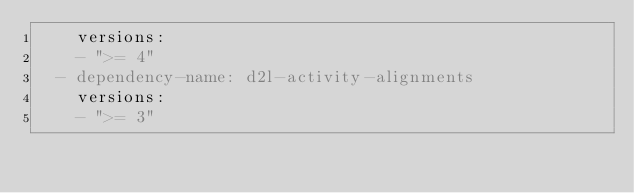Convert code to text. <code><loc_0><loc_0><loc_500><loc_500><_YAML_>    versions:
    - ">= 4"
  - dependency-name: d2l-activity-alignments
    versions:
    - ">= 3"
</code> 